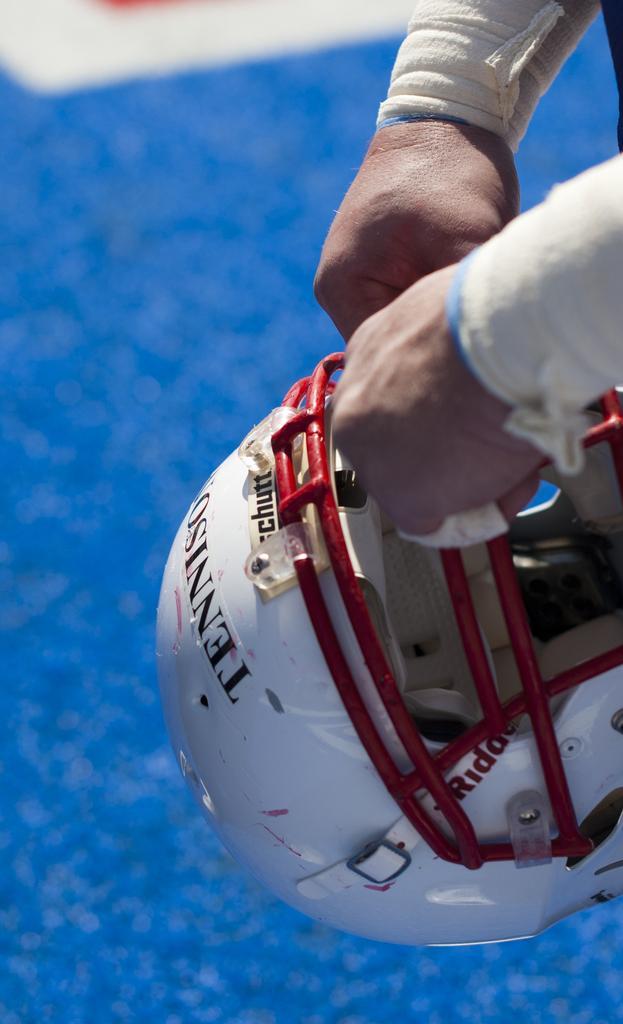In one or two sentences, can you explain what this image depicts? In this image I see a person's hands who is holding a helmet which is of red and white in color and I see something is written on it and I see that it is blue and white color in the background. 